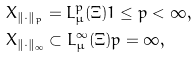<formula> <loc_0><loc_0><loc_500><loc_500>& X _ { \| \cdot \| _ { p } } = L ^ { p } _ { \mu } ( \Xi ) 1 \leq p < \infty , \\ & X _ { \| \cdot \| _ { \infty } } \subset L ^ { \infty } _ { \mu } ( \Xi ) p = \infty ,</formula> 